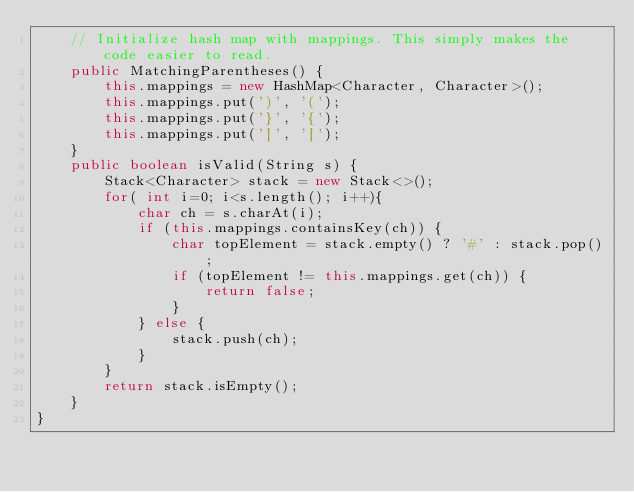Convert code to text. <code><loc_0><loc_0><loc_500><loc_500><_Java_>    // Initialize hash map with mappings. This simply makes the code easier to read.
    public MatchingParentheses() {
        this.mappings = new HashMap<Character, Character>();
        this.mappings.put(')', '(');
        this.mappings.put('}', '{');
        this.mappings.put(']', '[');
    }
    public boolean isValid(String s) {
        Stack<Character> stack = new Stack<>();
        for( int i=0; i<s.length(); i++){
            char ch = s.charAt(i);
            if (this.mappings.containsKey(ch)) {
                char topElement = stack.empty() ? '#' : stack.pop();
                if (topElement != this.mappings.get(ch)) {
                    return false;
                }
            } else {
                stack.push(ch);
            }
        }
        return stack.isEmpty();
    }
}
</code> 